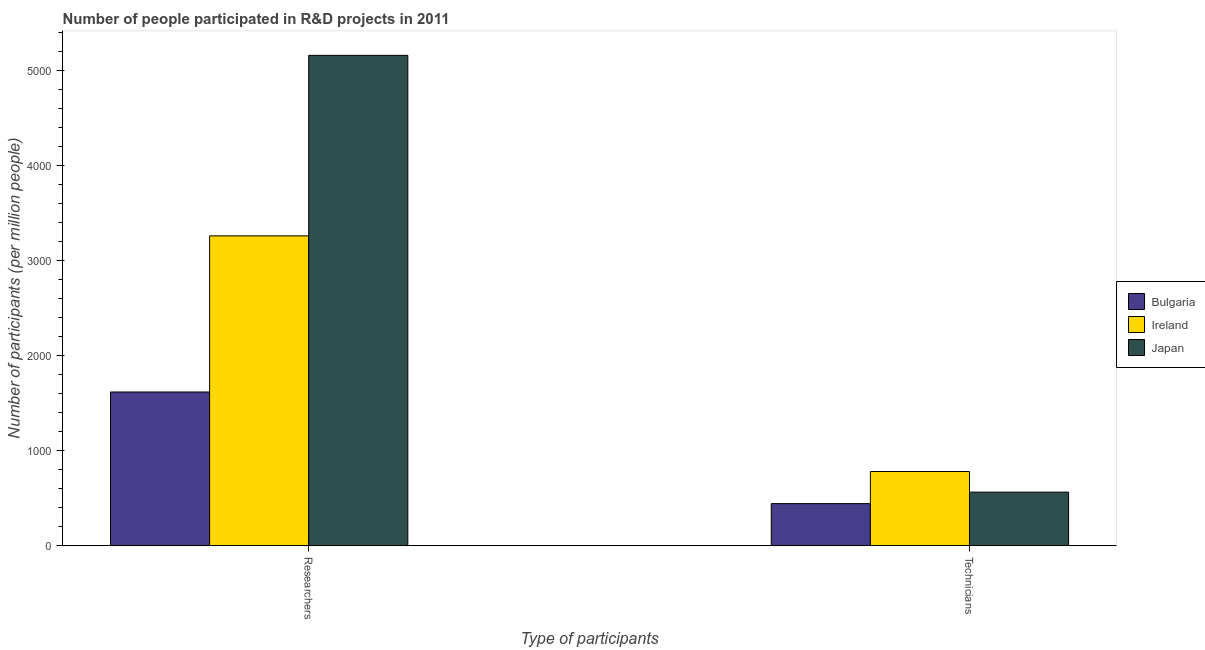How many groups of bars are there?
Your response must be concise. 2. How many bars are there on the 1st tick from the right?
Keep it short and to the point. 3. What is the label of the 1st group of bars from the left?
Offer a terse response. Researchers. What is the number of researchers in Bulgaria?
Make the answer very short. 1618.17. Across all countries, what is the maximum number of researchers?
Your answer should be very brief. 5160.2. Across all countries, what is the minimum number of researchers?
Offer a terse response. 1618.17. In which country was the number of technicians maximum?
Your answer should be very brief. Ireland. In which country was the number of technicians minimum?
Your response must be concise. Bulgaria. What is the total number of technicians in the graph?
Your response must be concise. 1789.5. What is the difference between the number of technicians in Ireland and that in Bulgaria?
Make the answer very short. 337.63. What is the difference between the number of technicians in Ireland and the number of researchers in Bulgaria?
Offer a very short reply. -836.9. What is the average number of researchers per country?
Provide a succinct answer. 3346.42. What is the difference between the number of technicians and number of researchers in Bulgaria?
Give a very brief answer. -1174.54. What is the ratio of the number of researchers in Bulgaria to that in Japan?
Make the answer very short. 0.31. Are all the bars in the graph horizontal?
Ensure brevity in your answer.  No. What is the difference between two consecutive major ticks on the Y-axis?
Your answer should be very brief. 1000. Does the graph contain any zero values?
Keep it short and to the point. No. Where does the legend appear in the graph?
Ensure brevity in your answer.  Center right. What is the title of the graph?
Provide a succinct answer. Number of people participated in R&D projects in 2011. What is the label or title of the X-axis?
Give a very brief answer. Type of participants. What is the label or title of the Y-axis?
Ensure brevity in your answer.  Number of participants (per million people). What is the Number of participants (per million people) of Bulgaria in Researchers?
Offer a very short reply. 1618.17. What is the Number of participants (per million people) in Ireland in Researchers?
Provide a short and direct response. 3260.89. What is the Number of participants (per million people) of Japan in Researchers?
Offer a terse response. 5160.2. What is the Number of participants (per million people) of Bulgaria in Technicians?
Give a very brief answer. 443.63. What is the Number of participants (per million people) of Ireland in Technicians?
Give a very brief answer. 781.26. What is the Number of participants (per million people) in Japan in Technicians?
Give a very brief answer. 564.61. Across all Type of participants, what is the maximum Number of participants (per million people) in Bulgaria?
Keep it short and to the point. 1618.17. Across all Type of participants, what is the maximum Number of participants (per million people) of Ireland?
Your response must be concise. 3260.89. Across all Type of participants, what is the maximum Number of participants (per million people) of Japan?
Keep it short and to the point. 5160.2. Across all Type of participants, what is the minimum Number of participants (per million people) in Bulgaria?
Make the answer very short. 443.63. Across all Type of participants, what is the minimum Number of participants (per million people) in Ireland?
Your response must be concise. 781.26. Across all Type of participants, what is the minimum Number of participants (per million people) in Japan?
Offer a terse response. 564.61. What is the total Number of participants (per million people) of Bulgaria in the graph?
Provide a succinct answer. 2061.8. What is the total Number of participants (per million people) of Ireland in the graph?
Your response must be concise. 4042.16. What is the total Number of participants (per million people) of Japan in the graph?
Your response must be concise. 5724.81. What is the difference between the Number of participants (per million people) in Bulgaria in Researchers and that in Technicians?
Ensure brevity in your answer.  1174.54. What is the difference between the Number of participants (per million people) of Ireland in Researchers and that in Technicians?
Your response must be concise. 2479.63. What is the difference between the Number of participants (per million people) of Japan in Researchers and that in Technicians?
Offer a terse response. 4595.6. What is the difference between the Number of participants (per million people) of Bulgaria in Researchers and the Number of participants (per million people) of Ireland in Technicians?
Ensure brevity in your answer.  836.9. What is the difference between the Number of participants (per million people) in Bulgaria in Researchers and the Number of participants (per million people) in Japan in Technicians?
Keep it short and to the point. 1053.56. What is the difference between the Number of participants (per million people) of Ireland in Researchers and the Number of participants (per million people) of Japan in Technicians?
Your answer should be compact. 2696.28. What is the average Number of participants (per million people) of Bulgaria per Type of participants?
Offer a terse response. 1030.9. What is the average Number of participants (per million people) of Ireland per Type of participants?
Offer a terse response. 2021.08. What is the average Number of participants (per million people) of Japan per Type of participants?
Ensure brevity in your answer.  2862.41. What is the difference between the Number of participants (per million people) in Bulgaria and Number of participants (per million people) in Ireland in Researchers?
Keep it short and to the point. -1642.72. What is the difference between the Number of participants (per million people) of Bulgaria and Number of participants (per million people) of Japan in Researchers?
Ensure brevity in your answer.  -3542.04. What is the difference between the Number of participants (per million people) in Ireland and Number of participants (per million people) in Japan in Researchers?
Make the answer very short. -1899.31. What is the difference between the Number of participants (per million people) of Bulgaria and Number of participants (per million people) of Ireland in Technicians?
Your answer should be compact. -337.63. What is the difference between the Number of participants (per million people) of Bulgaria and Number of participants (per million people) of Japan in Technicians?
Make the answer very short. -120.98. What is the difference between the Number of participants (per million people) in Ireland and Number of participants (per million people) in Japan in Technicians?
Your answer should be very brief. 216.66. What is the ratio of the Number of participants (per million people) of Bulgaria in Researchers to that in Technicians?
Your answer should be compact. 3.65. What is the ratio of the Number of participants (per million people) of Ireland in Researchers to that in Technicians?
Your answer should be compact. 4.17. What is the ratio of the Number of participants (per million people) of Japan in Researchers to that in Technicians?
Offer a very short reply. 9.14. What is the difference between the highest and the second highest Number of participants (per million people) in Bulgaria?
Provide a short and direct response. 1174.54. What is the difference between the highest and the second highest Number of participants (per million people) of Ireland?
Offer a very short reply. 2479.63. What is the difference between the highest and the second highest Number of participants (per million people) of Japan?
Offer a terse response. 4595.6. What is the difference between the highest and the lowest Number of participants (per million people) in Bulgaria?
Your response must be concise. 1174.54. What is the difference between the highest and the lowest Number of participants (per million people) of Ireland?
Your answer should be very brief. 2479.63. What is the difference between the highest and the lowest Number of participants (per million people) in Japan?
Provide a short and direct response. 4595.6. 